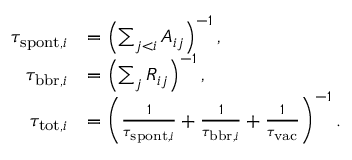Convert formula to latex. <formula><loc_0><loc_0><loc_500><loc_500>\begin{array} { r l } { \tau _ { s p o n t , i } } & { = \left ( \sum _ { j < i } A _ { i j } \right ) ^ { - 1 } , } \\ { \tau _ { b b r , i } } & { = \left ( \sum _ { j } R _ { i j } \right ) ^ { - 1 } , } \\ { \tau _ { t o t , i } } & { = \left ( \frac { 1 } { \tau _ { s p o n t , i } } + \frac { 1 } { \tau _ { b b r , i } } + \frac { 1 } { \tau _ { v a c } } \right ) ^ { - 1 } . } \end{array}</formula> 